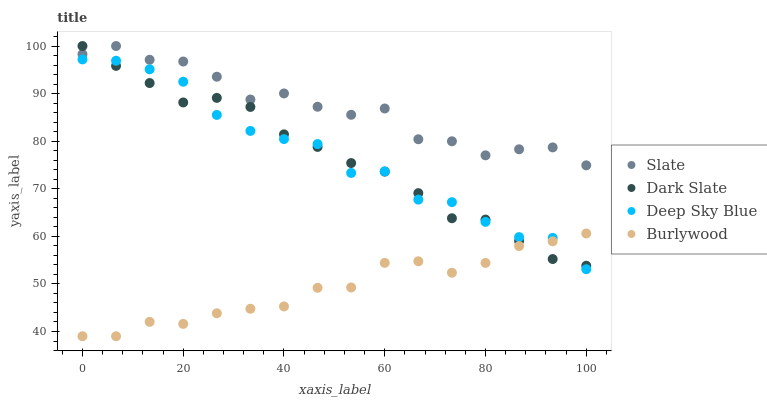Does Burlywood have the minimum area under the curve?
Answer yes or no. Yes. Does Slate have the maximum area under the curve?
Answer yes or no. Yes. Does Dark Slate have the minimum area under the curve?
Answer yes or no. No. Does Dark Slate have the maximum area under the curve?
Answer yes or no. No. Is Dark Slate the smoothest?
Answer yes or no. Yes. Is Slate the roughest?
Answer yes or no. Yes. Is Slate the smoothest?
Answer yes or no. No. Is Dark Slate the roughest?
Answer yes or no. No. Does Burlywood have the lowest value?
Answer yes or no. Yes. Does Dark Slate have the lowest value?
Answer yes or no. No. Does Slate have the highest value?
Answer yes or no. Yes. Does Deep Sky Blue have the highest value?
Answer yes or no. No. Is Deep Sky Blue less than Slate?
Answer yes or no. Yes. Is Slate greater than Deep Sky Blue?
Answer yes or no. Yes. Does Dark Slate intersect Slate?
Answer yes or no. Yes. Is Dark Slate less than Slate?
Answer yes or no. No. Is Dark Slate greater than Slate?
Answer yes or no. No. Does Deep Sky Blue intersect Slate?
Answer yes or no. No. 